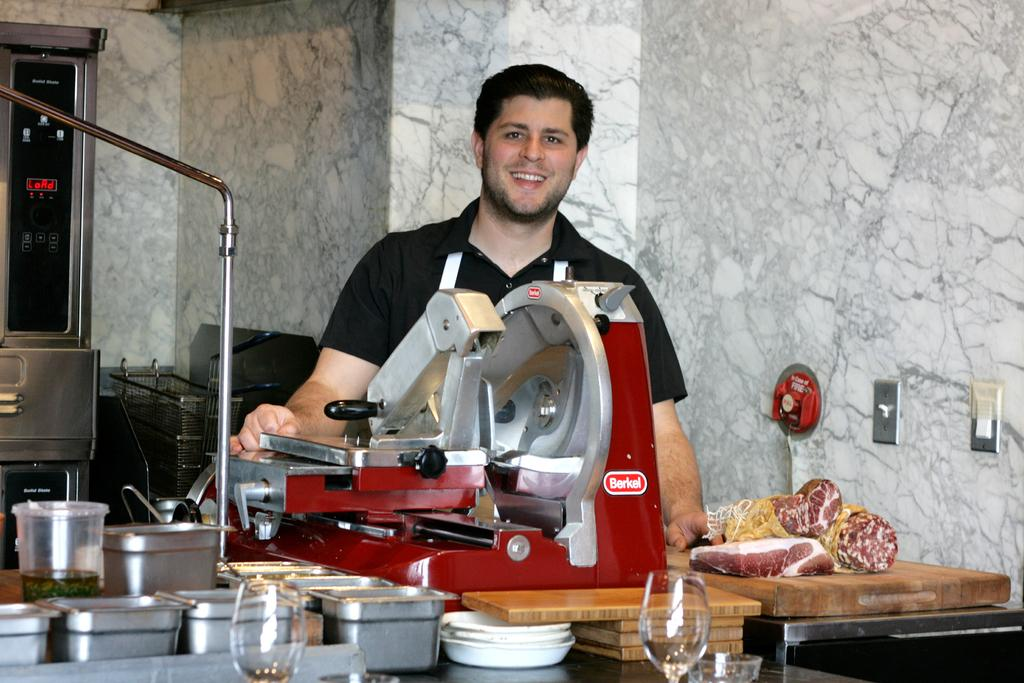<image>
Offer a succinct explanation of the picture presented. A man in an apron is standing behind a Berkel meat slicer. 